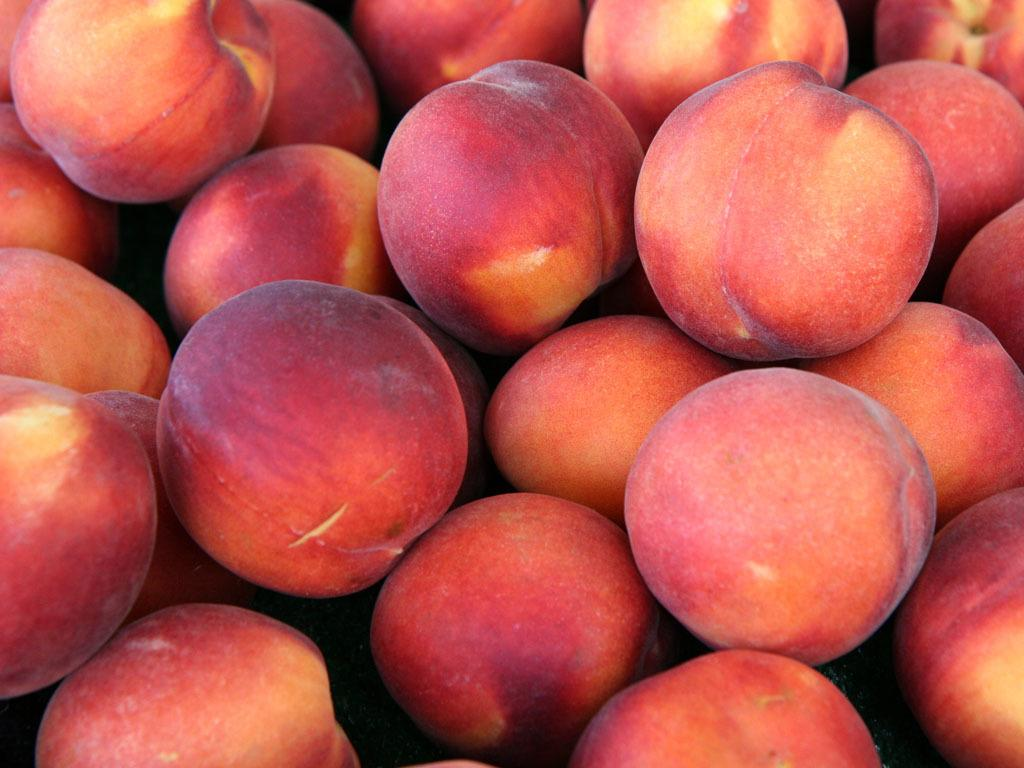What type of fruit is visible in the image? There is a group of apples in the image. How many apples are in the group? The number of apples in the group cannot be determined from the image alone. What color are the apples? The color of the apples cannot be determined from the image alone. What type of leather is used to make the dad's grade in the image? There is no leather, dad, or grade present in the image; it only features a group of apples. 